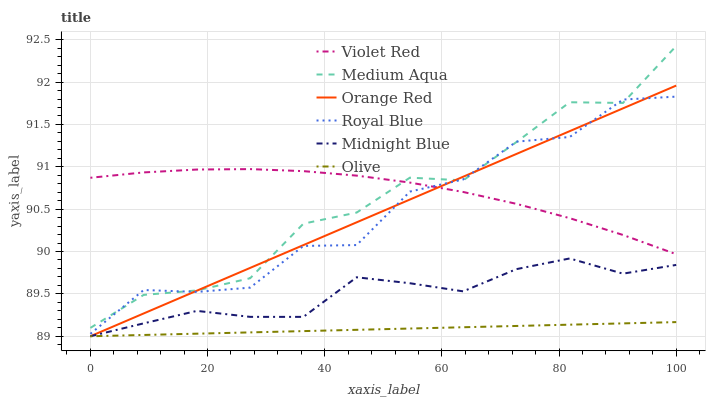Does Olive have the minimum area under the curve?
Answer yes or no. Yes. Does Violet Red have the maximum area under the curve?
Answer yes or no. Yes. Does Midnight Blue have the minimum area under the curve?
Answer yes or no. No. Does Midnight Blue have the maximum area under the curve?
Answer yes or no. No. Is Orange Red the smoothest?
Answer yes or no. Yes. Is Royal Blue the roughest?
Answer yes or no. Yes. Is Midnight Blue the smoothest?
Answer yes or no. No. Is Midnight Blue the roughest?
Answer yes or no. No. Does Midnight Blue have the lowest value?
Answer yes or no. Yes. Does Royal Blue have the lowest value?
Answer yes or no. No. Does Medium Aqua have the highest value?
Answer yes or no. Yes. Does Midnight Blue have the highest value?
Answer yes or no. No. Is Olive less than Medium Aqua?
Answer yes or no. Yes. Is Medium Aqua greater than Olive?
Answer yes or no. Yes. Does Royal Blue intersect Medium Aqua?
Answer yes or no. Yes. Is Royal Blue less than Medium Aqua?
Answer yes or no. No. Is Royal Blue greater than Medium Aqua?
Answer yes or no. No. Does Olive intersect Medium Aqua?
Answer yes or no. No. 